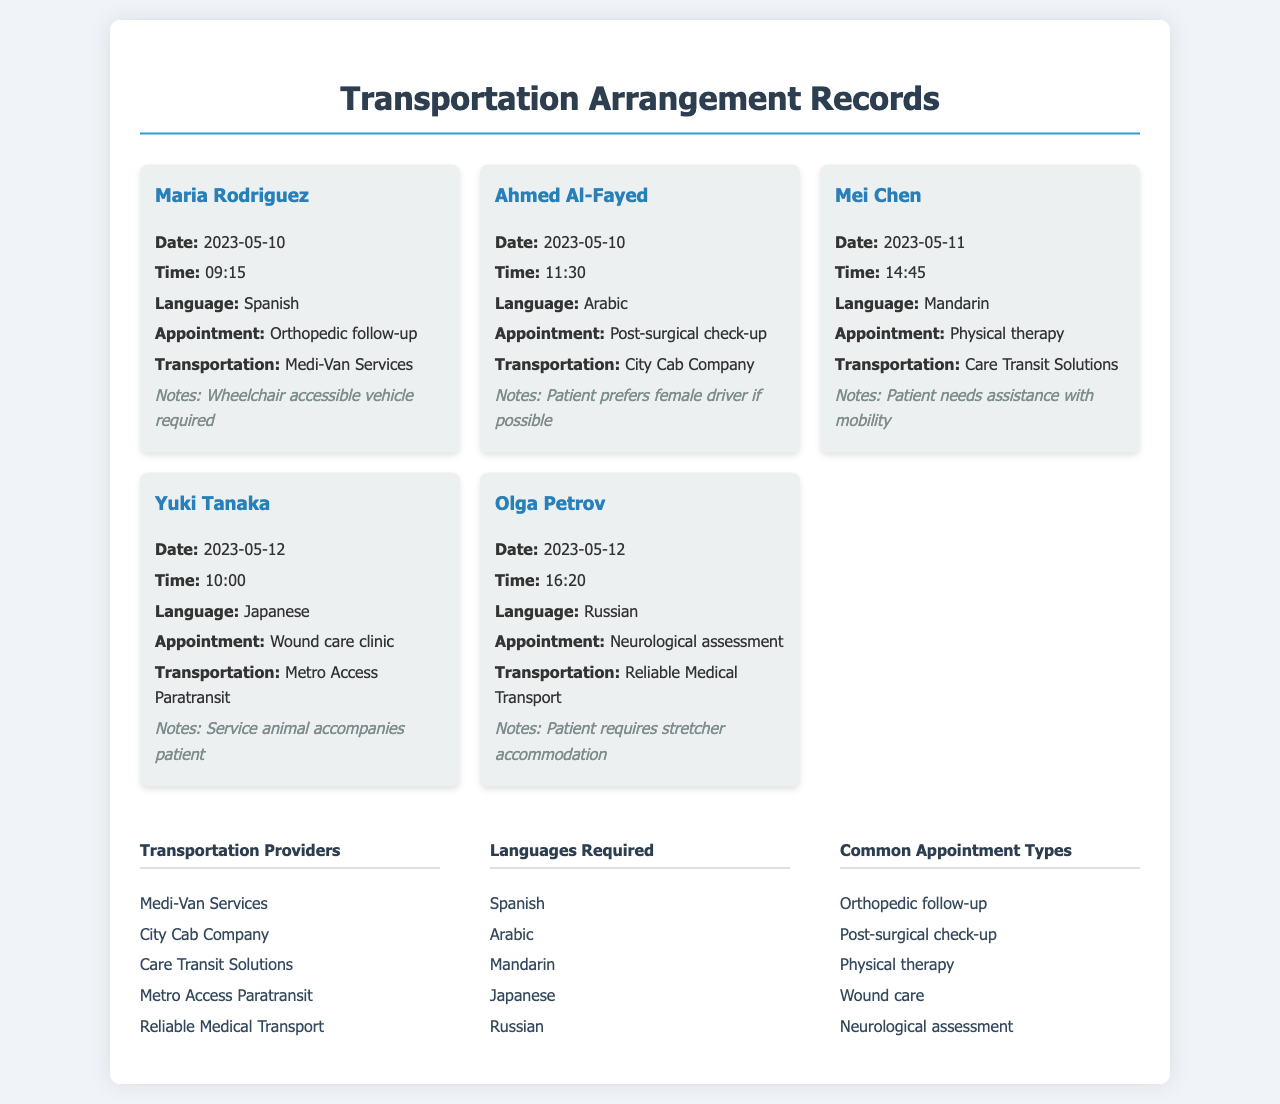What is the name of the patient with a follow-up appointment on May 10? The document lists Maria Rodriguez as the patient with a follow-up appointment on May 10.
Answer: Maria Rodriguez What type of transportation was arranged for Yuki Tanaka? The document specifies that Metro Access Paratransit was arranged for Yuki Tanaka.
Answer: Metro Access Paratransit How many patients required transportation services on May 12? There are two patients listed (Yuki Tanaka and Olga Petrov) requiring transportation services on May 12.
Answer: 2 What language does Ahmed Al-Fayed speak? The document indicates that Ahmed Al-Fayed speaks Arabic.
Answer: Arabic What special requirement did Olga Petrov have for transportation? The notes for Olga Petrov mention that she requires stretcher accommodation.
Answer: Stretcher accommodation Which patient needs assistance with mobility? Mei Chen's notes specify that she needs assistance with mobility.
Answer: Mei Chen What type of appointment did Maria Rodriguez have? Maria Rodriguez had an orthopedic follow-up appointment.
Answer: Orthopedic follow-up Which transportation provider is listed for physical therapy appointments? Care Transit Solutions is listed as the transportation provider for Mei Chen's physical therapy appointment.
Answer: Care Transit Solutions What is the appointment type for Ahmed Al-Fayed? The document states that Ahmed Al-Fayed has a post-surgical check-up appointment.
Answer: Post-surgical check-up 